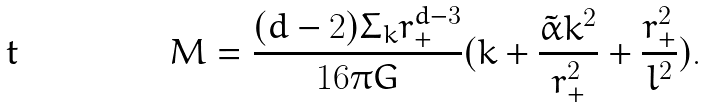Convert formula to latex. <formula><loc_0><loc_0><loc_500><loc_500>M = \frac { ( d - 2 ) \Sigma _ { k } r _ { + } ^ { d - 3 } } { 1 6 \pi G } ( k + \frac { \tilde { \alpha } k ^ { 2 } } { r _ { + } ^ { 2 } } + \frac { r _ { + } ^ { 2 } } { l ^ { 2 } } ) .</formula> 